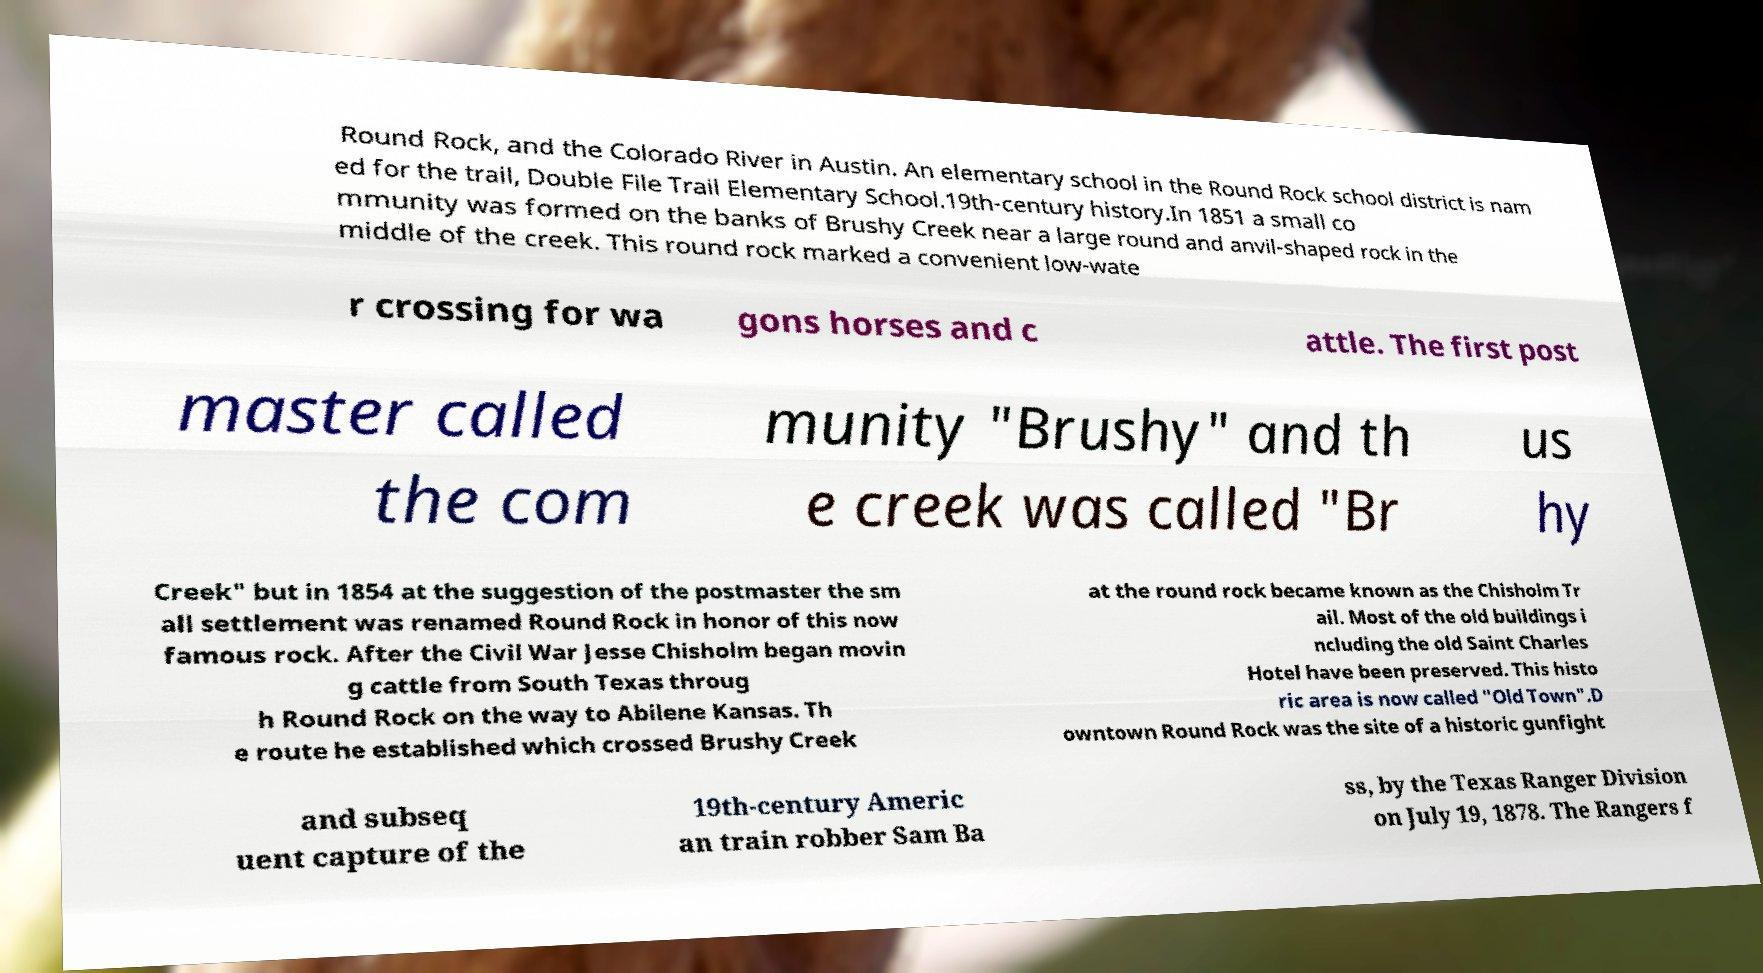There's text embedded in this image that I need extracted. Can you transcribe it verbatim? Round Rock, and the Colorado River in Austin. An elementary school in the Round Rock school district is nam ed for the trail, Double File Trail Elementary School.19th-century history.In 1851 a small co mmunity was formed on the banks of Brushy Creek near a large round and anvil-shaped rock in the middle of the creek. This round rock marked a convenient low-wate r crossing for wa gons horses and c attle. The first post master called the com munity "Brushy" and th e creek was called "Br us hy Creek" but in 1854 at the suggestion of the postmaster the sm all settlement was renamed Round Rock in honor of this now famous rock. After the Civil War Jesse Chisholm began movin g cattle from South Texas throug h Round Rock on the way to Abilene Kansas. Th e route he established which crossed Brushy Creek at the round rock became known as the Chisholm Tr ail. Most of the old buildings i ncluding the old Saint Charles Hotel have been preserved. This histo ric area is now called "Old Town".D owntown Round Rock was the site of a historic gunfight and subseq uent capture of the 19th-century Americ an train robber Sam Ba ss, by the Texas Ranger Division on July 19, 1878. The Rangers f 